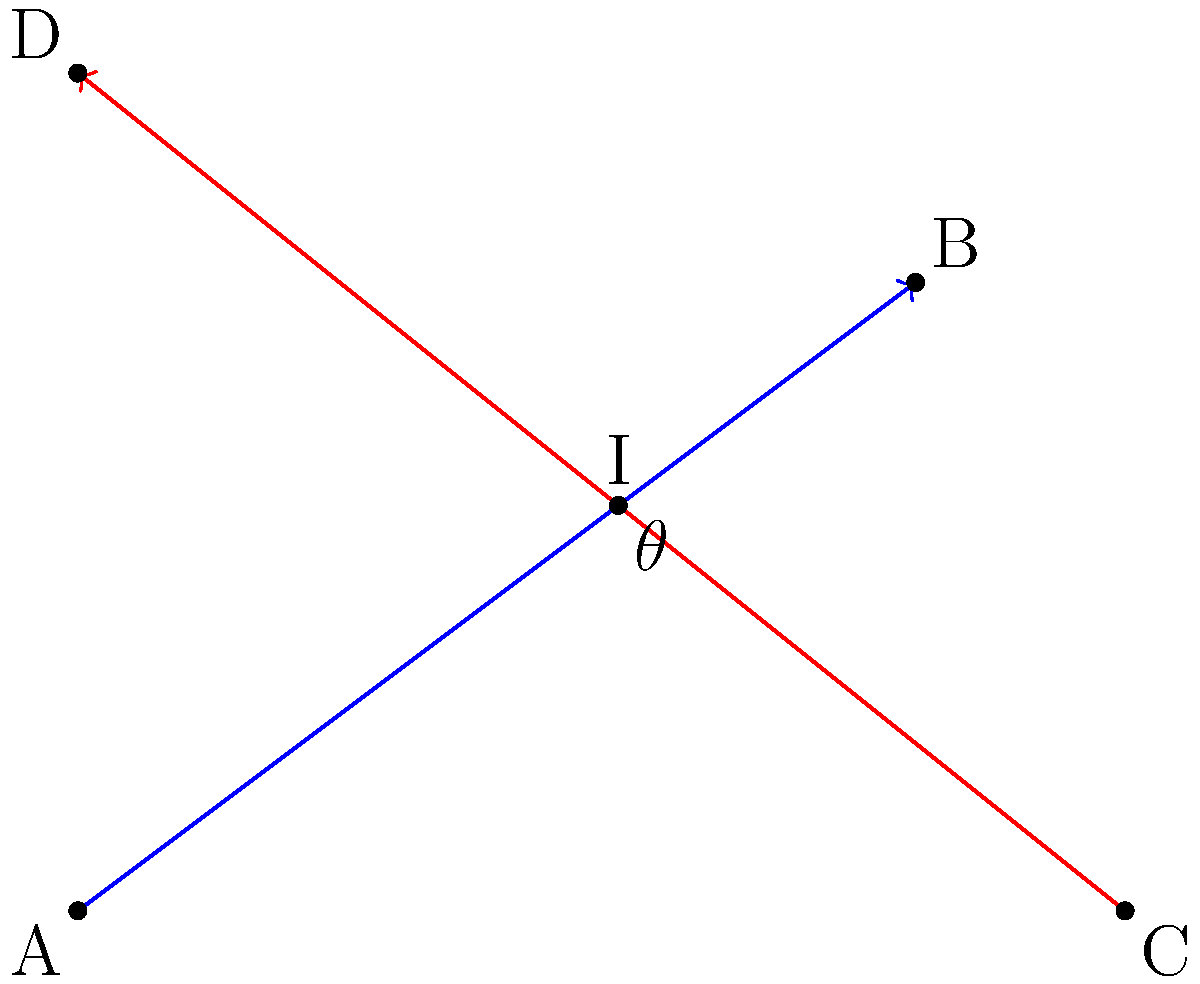In your innovative campaign strategy, two paths are represented by lines AB and CD. Line AB represents your digital marketing approach, while line CD represents your grassroots outreach strategy. If the coordinates of the points are A(0,0), B(4,3), C(5,0), and D(0,4), calculate the angle $\theta$ at which these strategy paths intersect. Round your answer to the nearest degree. To find the angle of intersection, we'll follow these steps:

1) First, calculate the slopes of both lines:

   Slope of AB: $m_1 = \frac{3-0}{4-0} = \frac{3}{4}$
   Slope of CD: $m_2 = \frac{4-0}{0-5} = -\frac{4}{5}$

2) Use the formula for the angle between two lines:

   $\tan \theta = |\frac{m_2 - m_1}{1 + m_1m_2}|$

3) Substitute the values:

   $\tan \theta = |\frac{(-\frac{4}{5}) - (\frac{3}{4})}{1 + (\frac{3}{4})(-\frac{4}{5})}|$

4) Simplify:

   $\tan \theta = |\frac{-16/20 - 15/20}{1 - 12/20}| = |\frac{-31/20}{8/20}| = \frac{31}{8}$

5) Take the inverse tangent and convert to degrees:

   $\theta = \arctan(\frac{31}{8}) \approx 75.52°$

6) Round to the nearest degree:

   $\theta \approx 76°$
Answer: 76° 